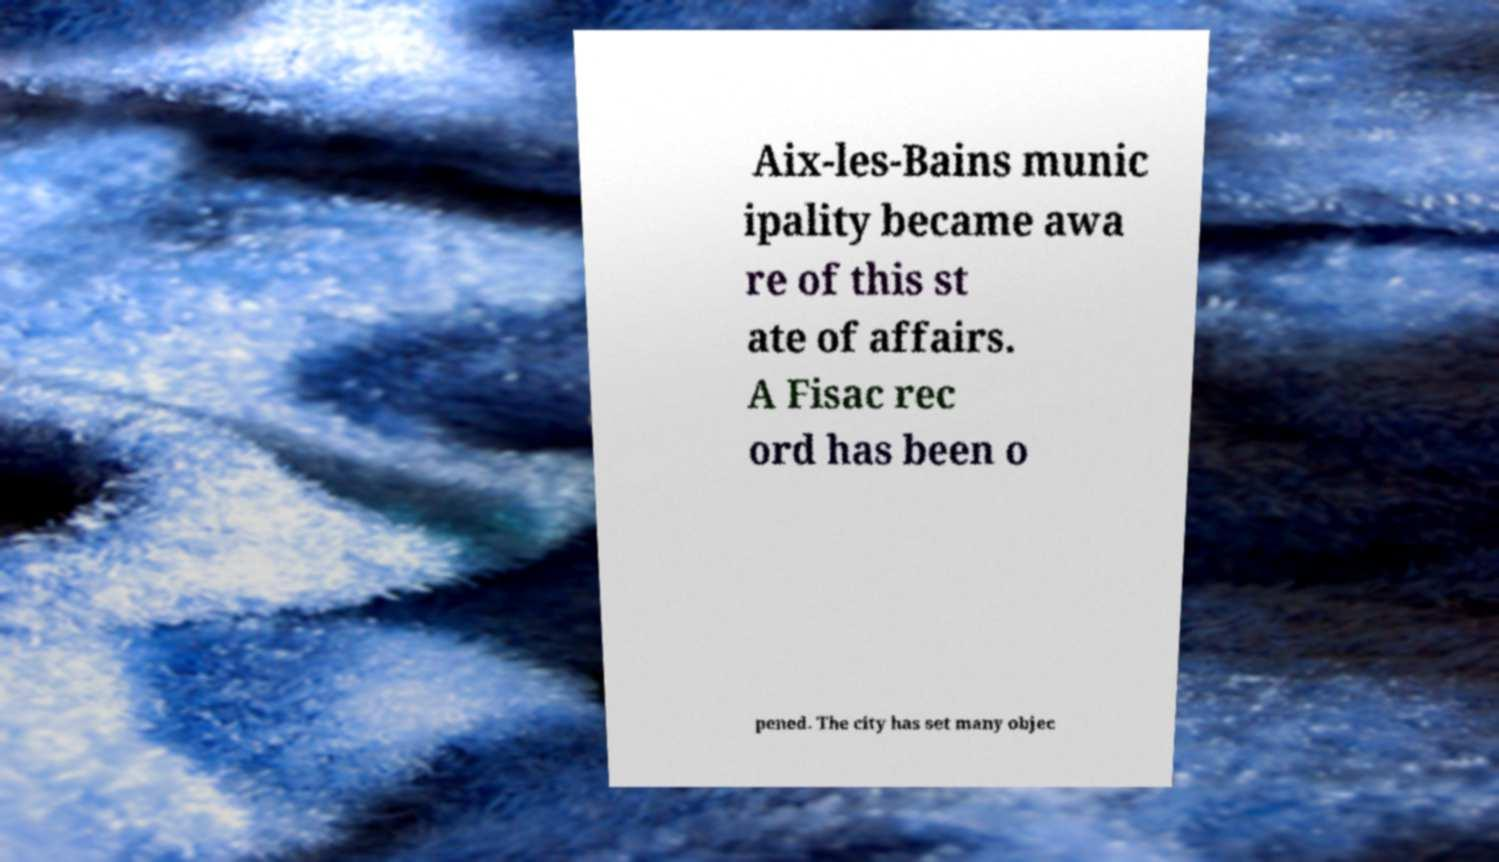There's text embedded in this image that I need extracted. Can you transcribe it verbatim? Aix-les-Bains munic ipality became awa re of this st ate of affairs. A Fisac rec ord has been o pened. The city has set many objec 